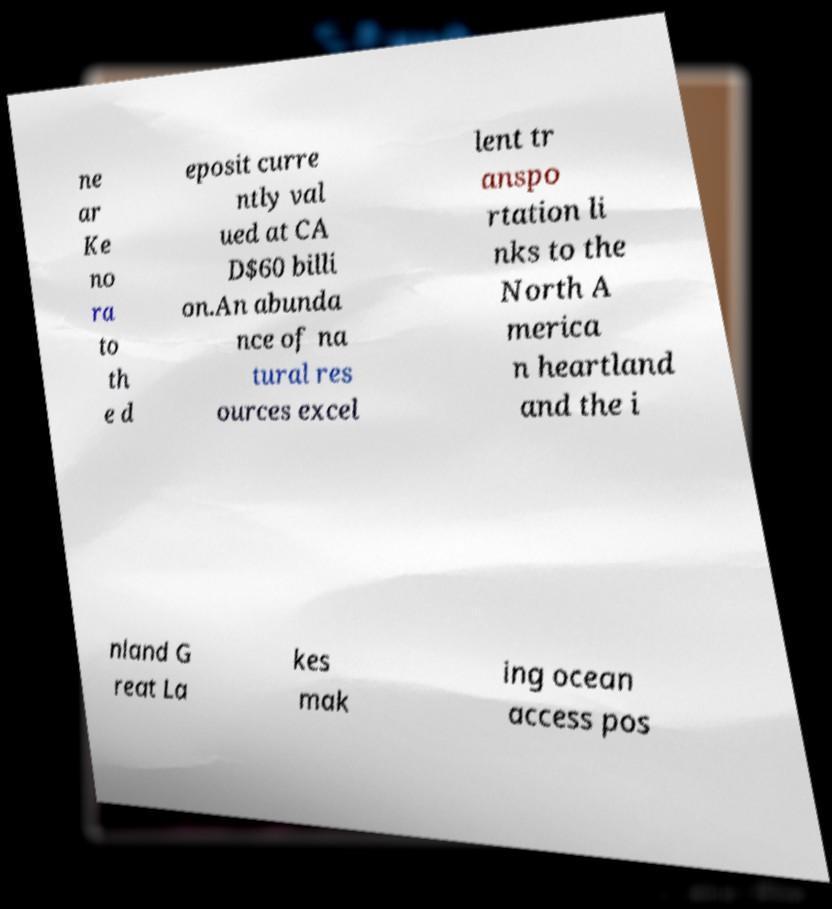What messages or text are displayed in this image? I need them in a readable, typed format. ne ar Ke no ra to th e d eposit curre ntly val ued at CA D$60 billi on.An abunda nce of na tural res ources excel lent tr anspo rtation li nks to the North A merica n heartland and the i nland G reat La kes mak ing ocean access pos 